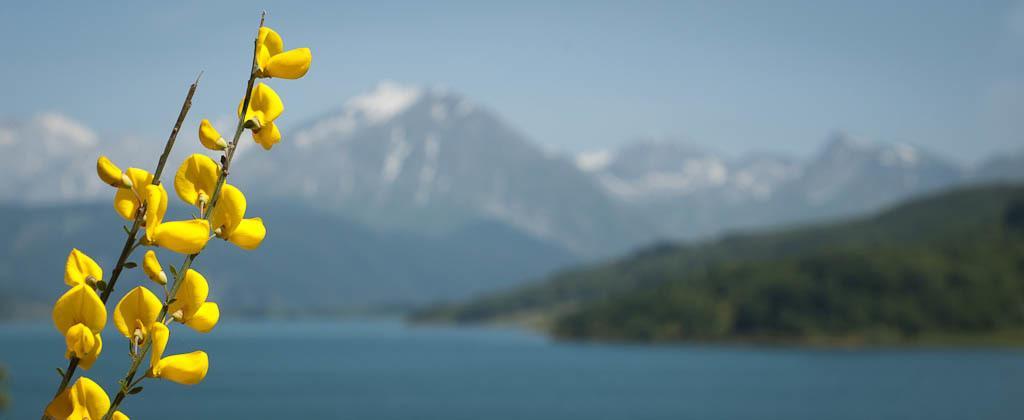Can you describe this image briefly? In this image we can see the yellow flowers on the left side. Here we can see the water. In the background, we can see the mountains. This is a sky with clouds. 